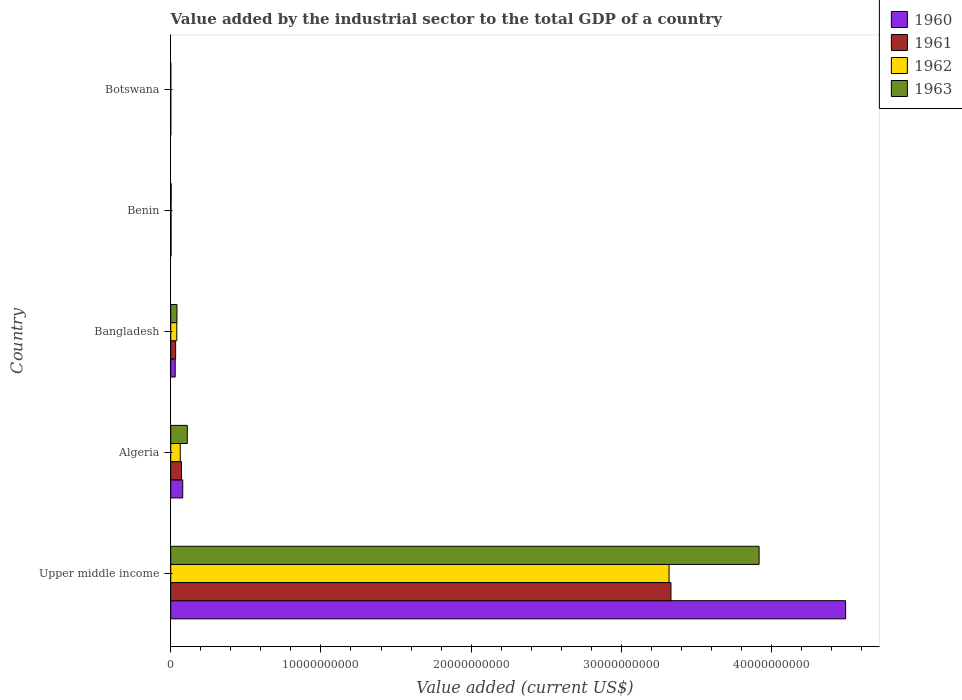How many groups of bars are there?
Provide a short and direct response. 5. Are the number of bars on each tick of the Y-axis equal?
Your response must be concise. Yes. How many bars are there on the 4th tick from the bottom?
Your response must be concise. 4. What is the label of the 5th group of bars from the top?
Your answer should be very brief. Upper middle income. What is the value added by the industrial sector to the total GDP in 1961 in Upper middle income?
Offer a terse response. 3.33e+1. Across all countries, what is the maximum value added by the industrial sector to the total GDP in 1963?
Provide a short and direct response. 3.92e+1. Across all countries, what is the minimum value added by the industrial sector to the total GDP in 1963?
Offer a terse response. 4.04e+06. In which country was the value added by the industrial sector to the total GDP in 1962 maximum?
Your answer should be very brief. Upper middle income. In which country was the value added by the industrial sector to the total GDP in 1962 minimum?
Keep it short and to the point. Botswana. What is the total value added by the industrial sector to the total GDP in 1963 in the graph?
Give a very brief answer. 4.07e+1. What is the difference between the value added by the industrial sector to the total GDP in 1962 in Bangladesh and that in Upper middle income?
Make the answer very short. -3.28e+1. What is the difference between the value added by the industrial sector to the total GDP in 1962 in Botswana and the value added by the industrial sector to the total GDP in 1960 in Bangladesh?
Provide a succinct answer. -2.94e+08. What is the average value added by the industrial sector to the total GDP in 1963 per country?
Your response must be concise. 8.15e+09. What is the difference between the value added by the industrial sector to the total GDP in 1961 and value added by the industrial sector to the total GDP in 1960 in Bangladesh?
Keep it short and to the point. 2.92e+07. What is the ratio of the value added by the industrial sector to the total GDP in 1960 in Benin to that in Botswana?
Make the answer very short. 5.71. Is the value added by the industrial sector to the total GDP in 1962 in Benin less than that in Botswana?
Keep it short and to the point. No. What is the difference between the highest and the second highest value added by the industrial sector to the total GDP in 1961?
Ensure brevity in your answer.  3.26e+1. What is the difference between the highest and the lowest value added by the industrial sector to the total GDP in 1962?
Your answer should be very brief. 3.32e+1. Is the sum of the value added by the industrial sector to the total GDP in 1961 in Benin and Botswana greater than the maximum value added by the industrial sector to the total GDP in 1960 across all countries?
Offer a terse response. No. Is it the case that in every country, the sum of the value added by the industrial sector to the total GDP in 1962 and value added by the industrial sector to the total GDP in 1963 is greater than the sum of value added by the industrial sector to the total GDP in 1961 and value added by the industrial sector to the total GDP in 1960?
Give a very brief answer. No. What does the 4th bar from the bottom in Benin represents?
Offer a terse response. 1963. Is it the case that in every country, the sum of the value added by the industrial sector to the total GDP in 1961 and value added by the industrial sector to the total GDP in 1960 is greater than the value added by the industrial sector to the total GDP in 1962?
Give a very brief answer. Yes. How many bars are there?
Offer a very short reply. 20. What is the difference between two consecutive major ticks on the X-axis?
Give a very brief answer. 1.00e+1. Does the graph contain any zero values?
Keep it short and to the point. No. Does the graph contain grids?
Make the answer very short. No. How are the legend labels stacked?
Your answer should be compact. Vertical. What is the title of the graph?
Ensure brevity in your answer.  Value added by the industrial sector to the total GDP of a country. What is the label or title of the X-axis?
Keep it short and to the point. Value added (current US$). What is the label or title of the Y-axis?
Keep it short and to the point. Country. What is the Value added (current US$) of 1960 in Upper middle income?
Ensure brevity in your answer.  4.49e+1. What is the Value added (current US$) in 1961 in Upper middle income?
Make the answer very short. 3.33e+1. What is the Value added (current US$) in 1962 in Upper middle income?
Offer a terse response. 3.32e+1. What is the Value added (current US$) in 1963 in Upper middle income?
Offer a very short reply. 3.92e+1. What is the Value added (current US$) in 1960 in Algeria?
Make the answer very short. 8.00e+08. What is the Value added (current US$) of 1961 in Algeria?
Give a very brief answer. 7.17e+08. What is the Value added (current US$) of 1962 in Algeria?
Make the answer very short. 6.34e+08. What is the Value added (current US$) in 1963 in Algeria?
Give a very brief answer. 1.10e+09. What is the Value added (current US$) of 1960 in Bangladesh?
Keep it short and to the point. 2.98e+08. What is the Value added (current US$) in 1961 in Bangladesh?
Ensure brevity in your answer.  3.27e+08. What is the Value added (current US$) of 1962 in Bangladesh?
Provide a short and direct response. 4.05e+08. What is the Value added (current US$) of 1963 in Bangladesh?
Provide a short and direct response. 4.15e+08. What is the Value added (current US$) of 1960 in Benin?
Keep it short and to the point. 2.31e+07. What is the Value added (current US$) of 1961 in Benin?
Keep it short and to the point. 2.31e+07. What is the Value added (current US$) of 1962 in Benin?
Provide a short and direct response. 2.32e+07. What is the Value added (current US$) in 1963 in Benin?
Provide a short and direct response. 2.91e+07. What is the Value added (current US$) of 1960 in Botswana?
Provide a succinct answer. 4.05e+06. What is the Value added (current US$) in 1961 in Botswana?
Your answer should be very brief. 4.05e+06. What is the Value added (current US$) of 1962 in Botswana?
Offer a very short reply. 4.05e+06. What is the Value added (current US$) of 1963 in Botswana?
Your answer should be compact. 4.04e+06. Across all countries, what is the maximum Value added (current US$) of 1960?
Your answer should be very brief. 4.49e+1. Across all countries, what is the maximum Value added (current US$) of 1961?
Provide a succinct answer. 3.33e+1. Across all countries, what is the maximum Value added (current US$) of 1962?
Your response must be concise. 3.32e+1. Across all countries, what is the maximum Value added (current US$) of 1963?
Provide a short and direct response. 3.92e+1. Across all countries, what is the minimum Value added (current US$) in 1960?
Keep it short and to the point. 4.05e+06. Across all countries, what is the minimum Value added (current US$) in 1961?
Ensure brevity in your answer.  4.05e+06. Across all countries, what is the minimum Value added (current US$) in 1962?
Provide a short and direct response. 4.05e+06. Across all countries, what is the minimum Value added (current US$) in 1963?
Offer a very short reply. 4.04e+06. What is the total Value added (current US$) in 1960 in the graph?
Your answer should be very brief. 4.61e+1. What is the total Value added (current US$) of 1961 in the graph?
Your answer should be compact. 3.44e+1. What is the total Value added (current US$) in 1962 in the graph?
Make the answer very short. 3.42e+1. What is the total Value added (current US$) of 1963 in the graph?
Provide a succinct answer. 4.07e+1. What is the difference between the Value added (current US$) in 1960 in Upper middle income and that in Algeria?
Offer a terse response. 4.41e+1. What is the difference between the Value added (current US$) of 1961 in Upper middle income and that in Algeria?
Provide a short and direct response. 3.26e+1. What is the difference between the Value added (current US$) of 1962 in Upper middle income and that in Algeria?
Keep it short and to the point. 3.25e+1. What is the difference between the Value added (current US$) of 1963 in Upper middle income and that in Algeria?
Your response must be concise. 3.81e+1. What is the difference between the Value added (current US$) in 1960 in Upper middle income and that in Bangladesh?
Offer a very short reply. 4.46e+1. What is the difference between the Value added (current US$) in 1961 in Upper middle income and that in Bangladesh?
Ensure brevity in your answer.  3.30e+1. What is the difference between the Value added (current US$) in 1962 in Upper middle income and that in Bangladesh?
Offer a very short reply. 3.28e+1. What is the difference between the Value added (current US$) of 1963 in Upper middle income and that in Bangladesh?
Provide a short and direct response. 3.88e+1. What is the difference between the Value added (current US$) in 1960 in Upper middle income and that in Benin?
Make the answer very short. 4.49e+1. What is the difference between the Value added (current US$) in 1961 in Upper middle income and that in Benin?
Your answer should be very brief. 3.33e+1. What is the difference between the Value added (current US$) in 1962 in Upper middle income and that in Benin?
Provide a succinct answer. 3.32e+1. What is the difference between the Value added (current US$) of 1963 in Upper middle income and that in Benin?
Offer a terse response. 3.91e+1. What is the difference between the Value added (current US$) of 1960 in Upper middle income and that in Botswana?
Keep it short and to the point. 4.49e+1. What is the difference between the Value added (current US$) in 1961 in Upper middle income and that in Botswana?
Ensure brevity in your answer.  3.33e+1. What is the difference between the Value added (current US$) in 1962 in Upper middle income and that in Botswana?
Ensure brevity in your answer.  3.32e+1. What is the difference between the Value added (current US$) of 1963 in Upper middle income and that in Botswana?
Your response must be concise. 3.92e+1. What is the difference between the Value added (current US$) of 1960 in Algeria and that in Bangladesh?
Give a very brief answer. 5.02e+08. What is the difference between the Value added (current US$) of 1961 in Algeria and that in Bangladesh?
Offer a very short reply. 3.90e+08. What is the difference between the Value added (current US$) of 1962 in Algeria and that in Bangladesh?
Provide a succinct answer. 2.30e+08. What is the difference between the Value added (current US$) of 1963 in Algeria and that in Bangladesh?
Provide a short and direct response. 6.88e+08. What is the difference between the Value added (current US$) of 1960 in Algeria and that in Benin?
Give a very brief answer. 7.77e+08. What is the difference between the Value added (current US$) in 1961 in Algeria and that in Benin?
Your answer should be compact. 6.94e+08. What is the difference between the Value added (current US$) in 1962 in Algeria and that in Benin?
Your answer should be compact. 6.11e+08. What is the difference between the Value added (current US$) of 1963 in Algeria and that in Benin?
Make the answer very short. 1.07e+09. What is the difference between the Value added (current US$) in 1960 in Algeria and that in Botswana?
Give a very brief answer. 7.96e+08. What is the difference between the Value added (current US$) in 1961 in Algeria and that in Botswana?
Give a very brief answer. 7.13e+08. What is the difference between the Value added (current US$) of 1962 in Algeria and that in Botswana?
Your response must be concise. 6.30e+08. What is the difference between the Value added (current US$) of 1963 in Algeria and that in Botswana?
Offer a very short reply. 1.10e+09. What is the difference between the Value added (current US$) of 1960 in Bangladesh and that in Benin?
Provide a short and direct response. 2.75e+08. What is the difference between the Value added (current US$) of 1961 in Bangladesh and that in Benin?
Provide a short and direct response. 3.04e+08. What is the difference between the Value added (current US$) in 1962 in Bangladesh and that in Benin?
Offer a terse response. 3.82e+08. What is the difference between the Value added (current US$) of 1963 in Bangladesh and that in Benin?
Your answer should be compact. 3.86e+08. What is the difference between the Value added (current US$) of 1960 in Bangladesh and that in Botswana?
Your answer should be compact. 2.94e+08. What is the difference between the Value added (current US$) of 1961 in Bangladesh and that in Botswana?
Your answer should be very brief. 3.23e+08. What is the difference between the Value added (current US$) of 1962 in Bangladesh and that in Botswana?
Offer a very short reply. 4.01e+08. What is the difference between the Value added (current US$) in 1963 in Bangladesh and that in Botswana?
Make the answer very short. 4.11e+08. What is the difference between the Value added (current US$) of 1960 in Benin and that in Botswana?
Make the answer very short. 1.91e+07. What is the difference between the Value added (current US$) of 1961 in Benin and that in Botswana?
Keep it short and to the point. 1.91e+07. What is the difference between the Value added (current US$) of 1962 in Benin and that in Botswana?
Your response must be concise. 1.91e+07. What is the difference between the Value added (current US$) of 1963 in Benin and that in Botswana?
Provide a short and direct response. 2.51e+07. What is the difference between the Value added (current US$) in 1960 in Upper middle income and the Value added (current US$) in 1961 in Algeria?
Your response must be concise. 4.42e+1. What is the difference between the Value added (current US$) of 1960 in Upper middle income and the Value added (current US$) of 1962 in Algeria?
Your response must be concise. 4.43e+1. What is the difference between the Value added (current US$) of 1960 in Upper middle income and the Value added (current US$) of 1963 in Algeria?
Provide a succinct answer. 4.38e+1. What is the difference between the Value added (current US$) in 1961 in Upper middle income and the Value added (current US$) in 1962 in Algeria?
Offer a very short reply. 3.27e+1. What is the difference between the Value added (current US$) in 1961 in Upper middle income and the Value added (current US$) in 1963 in Algeria?
Ensure brevity in your answer.  3.22e+1. What is the difference between the Value added (current US$) of 1962 in Upper middle income and the Value added (current US$) of 1963 in Algeria?
Give a very brief answer. 3.21e+1. What is the difference between the Value added (current US$) of 1960 in Upper middle income and the Value added (current US$) of 1961 in Bangladesh?
Ensure brevity in your answer.  4.46e+1. What is the difference between the Value added (current US$) of 1960 in Upper middle income and the Value added (current US$) of 1962 in Bangladesh?
Give a very brief answer. 4.45e+1. What is the difference between the Value added (current US$) in 1960 in Upper middle income and the Value added (current US$) in 1963 in Bangladesh?
Your answer should be very brief. 4.45e+1. What is the difference between the Value added (current US$) in 1961 in Upper middle income and the Value added (current US$) in 1962 in Bangladesh?
Keep it short and to the point. 3.29e+1. What is the difference between the Value added (current US$) in 1961 in Upper middle income and the Value added (current US$) in 1963 in Bangladesh?
Offer a terse response. 3.29e+1. What is the difference between the Value added (current US$) of 1962 in Upper middle income and the Value added (current US$) of 1963 in Bangladesh?
Your response must be concise. 3.28e+1. What is the difference between the Value added (current US$) in 1960 in Upper middle income and the Value added (current US$) in 1961 in Benin?
Give a very brief answer. 4.49e+1. What is the difference between the Value added (current US$) of 1960 in Upper middle income and the Value added (current US$) of 1962 in Benin?
Offer a very short reply. 4.49e+1. What is the difference between the Value added (current US$) of 1960 in Upper middle income and the Value added (current US$) of 1963 in Benin?
Give a very brief answer. 4.49e+1. What is the difference between the Value added (current US$) of 1961 in Upper middle income and the Value added (current US$) of 1962 in Benin?
Give a very brief answer. 3.33e+1. What is the difference between the Value added (current US$) of 1961 in Upper middle income and the Value added (current US$) of 1963 in Benin?
Make the answer very short. 3.33e+1. What is the difference between the Value added (current US$) in 1962 in Upper middle income and the Value added (current US$) in 1963 in Benin?
Your answer should be very brief. 3.31e+1. What is the difference between the Value added (current US$) of 1960 in Upper middle income and the Value added (current US$) of 1961 in Botswana?
Your answer should be compact. 4.49e+1. What is the difference between the Value added (current US$) in 1960 in Upper middle income and the Value added (current US$) in 1962 in Botswana?
Your answer should be compact. 4.49e+1. What is the difference between the Value added (current US$) in 1960 in Upper middle income and the Value added (current US$) in 1963 in Botswana?
Give a very brief answer. 4.49e+1. What is the difference between the Value added (current US$) of 1961 in Upper middle income and the Value added (current US$) of 1962 in Botswana?
Your response must be concise. 3.33e+1. What is the difference between the Value added (current US$) in 1961 in Upper middle income and the Value added (current US$) in 1963 in Botswana?
Make the answer very short. 3.33e+1. What is the difference between the Value added (current US$) of 1962 in Upper middle income and the Value added (current US$) of 1963 in Botswana?
Provide a short and direct response. 3.32e+1. What is the difference between the Value added (current US$) in 1960 in Algeria and the Value added (current US$) in 1961 in Bangladesh?
Keep it short and to the point. 4.73e+08. What is the difference between the Value added (current US$) in 1960 in Algeria and the Value added (current US$) in 1962 in Bangladesh?
Ensure brevity in your answer.  3.95e+08. What is the difference between the Value added (current US$) in 1960 in Algeria and the Value added (current US$) in 1963 in Bangladesh?
Ensure brevity in your answer.  3.85e+08. What is the difference between the Value added (current US$) of 1961 in Algeria and the Value added (current US$) of 1962 in Bangladesh?
Provide a short and direct response. 3.12e+08. What is the difference between the Value added (current US$) in 1961 in Algeria and the Value added (current US$) in 1963 in Bangladesh?
Your answer should be compact. 3.02e+08. What is the difference between the Value added (current US$) of 1962 in Algeria and the Value added (current US$) of 1963 in Bangladesh?
Offer a very short reply. 2.19e+08. What is the difference between the Value added (current US$) of 1960 in Algeria and the Value added (current US$) of 1961 in Benin?
Ensure brevity in your answer.  7.77e+08. What is the difference between the Value added (current US$) of 1960 in Algeria and the Value added (current US$) of 1962 in Benin?
Offer a terse response. 7.77e+08. What is the difference between the Value added (current US$) in 1960 in Algeria and the Value added (current US$) in 1963 in Benin?
Give a very brief answer. 7.71e+08. What is the difference between the Value added (current US$) in 1961 in Algeria and the Value added (current US$) in 1962 in Benin?
Give a very brief answer. 6.94e+08. What is the difference between the Value added (current US$) in 1961 in Algeria and the Value added (current US$) in 1963 in Benin?
Your response must be concise. 6.88e+08. What is the difference between the Value added (current US$) of 1962 in Algeria and the Value added (current US$) of 1963 in Benin?
Offer a terse response. 6.05e+08. What is the difference between the Value added (current US$) of 1960 in Algeria and the Value added (current US$) of 1961 in Botswana?
Ensure brevity in your answer.  7.96e+08. What is the difference between the Value added (current US$) in 1960 in Algeria and the Value added (current US$) in 1962 in Botswana?
Your answer should be very brief. 7.96e+08. What is the difference between the Value added (current US$) in 1960 in Algeria and the Value added (current US$) in 1963 in Botswana?
Keep it short and to the point. 7.96e+08. What is the difference between the Value added (current US$) of 1961 in Algeria and the Value added (current US$) of 1962 in Botswana?
Provide a short and direct response. 7.13e+08. What is the difference between the Value added (current US$) in 1961 in Algeria and the Value added (current US$) in 1963 in Botswana?
Keep it short and to the point. 7.13e+08. What is the difference between the Value added (current US$) in 1962 in Algeria and the Value added (current US$) in 1963 in Botswana?
Offer a terse response. 6.30e+08. What is the difference between the Value added (current US$) of 1960 in Bangladesh and the Value added (current US$) of 1961 in Benin?
Offer a very short reply. 2.75e+08. What is the difference between the Value added (current US$) in 1960 in Bangladesh and the Value added (current US$) in 1962 in Benin?
Your answer should be compact. 2.75e+08. What is the difference between the Value added (current US$) of 1960 in Bangladesh and the Value added (current US$) of 1963 in Benin?
Your answer should be compact. 2.69e+08. What is the difference between the Value added (current US$) in 1961 in Bangladesh and the Value added (current US$) in 1962 in Benin?
Offer a very short reply. 3.04e+08. What is the difference between the Value added (current US$) in 1961 in Bangladesh and the Value added (current US$) in 1963 in Benin?
Keep it short and to the point. 2.98e+08. What is the difference between the Value added (current US$) in 1962 in Bangladesh and the Value added (current US$) in 1963 in Benin?
Your answer should be very brief. 3.76e+08. What is the difference between the Value added (current US$) in 1960 in Bangladesh and the Value added (current US$) in 1961 in Botswana?
Your answer should be compact. 2.94e+08. What is the difference between the Value added (current US$) in 1960 in Bangladesh and the Value added (current US$) in 1962 in Botswana?
Make the answer very short. 2.94e+08. What is the difference between the Value added (current US$) in 1960 in Bangladesh and the Value added (current US$) in 1963 in Botswana?
Make the answer very short. 2.94e+08. What is the difference between the Value added (current US$) in 1961 in Bangladesh and the Value added (current US$) in 1962 in Botswana?
Ensure brevity in your answer.  3.23e+08. What is the difference between the Value added (current US$) of 1961 in Bangladesh and the Value added (current US$) of 1963 in Botswana?
Offer a very short reply. 3.23e+08. What is the difference between the Value added (current US$) in 1962 in Bangladesh and the Value added (current US$) in 1963 in Botswana?
Your answer should be compact. 4.01e+08. What is the difference between the Value added (current US$) in 1960 in Benin and the Value added (current US$) in 1961 in Botswana?
Your answer should be very brief. 1.91e+07. What is the difference between the Value added (current US$) in 1960 in Benin and the Value added (current US$) in 1962 in Botswana?
Provide a short and direct response. 1.91e+07. What is the difference between the Value added (current US$) of 1960 in Benin and the Value added (current US$) of 1963 in Botswana?
Your answer should be very brief. 1.91e+07. What is the difference between the Value added (current US$) in 1961 in Benin and the Value added (current US$) in 1962 in Botswana?
Your answer should be compact. 1.91e+07. What is the difference between the Value added (current US$) of 1961 in Benin and the Value added (current US$) of 1963 in Botswana?
Your answer should be compact. 1.91e+07. What is the difference between the Value added (current US$) of 1962 in Benin and the Value added (current US$) of 1963 in Botswana?
Your response must be concise. 1.91e+07. What is the average Value added (current US$) of 1960 per country?
Keep it short and to the point. 9.21e+09. What is the average Value added (current US$) of 1961 per country?
Make the answer very short. 6.88e+09. What is the average Value added (current US$) of 1962 per country?
Your answer should be very brief. 6.85e+09. What is the average Value added (current US$) of 1963 per country?
Make the answer very short. 8.15e+09. What is the difference between the Value added (current US$) in 1960 and Value added (current US$) in 1961 in Upper middle income?
Provide a short and direct response. 1.16e+1. What is the difference between the Value added (current US$) in 1960 and Value added (current US$) in 1962 in Upper middle income?
Your answer should be very brief. 1.18e+1. What is the difference between the Value added (current US$) in 1960 and Value added (current US$) in 1963 in Upper middle income?
Offer a terse response. 5.76e+09. What is the difference between the Value added (current US$) of 1961 and Value added (current US$) of 1962 in Upper middle income?
Keep it short and to the point. 1.26e+08. What is the difference between the Value added (current US$) of 1961 and Value added (current US$) of 1963 in Upper middle income?
Your response must be concise. -5.87e+09. What is the difference between the Value added (current US$) in 1962 and Value added (current US$) in 1963 in Upper middle income?
Your response must be concise. -5.99e+09. What is the difference between the Value added (current US$) in 1960 and Value added (current US$) in 1961 in Algeria?
Make the answer very short. 8.27e+07. What is the difference between the Value added (current US$) in 1960 and Value added (current US$) in 1962 in Algeria?
Provide a short and direct response. 1.65e+08. What is the difference between the Value added (current US$) of 1960 and Value added (current US$) of 1963 in Algeria?
Your answer should be compact. -3.03e+08. What is the difference between the Value added (current US$) of 1961 and Value added (current US$) of 1962 in Algeria?
Make the answer very short. 8.27e+07. What is the difference between the Value added (current US$) in 1961 and Value added (current US$) in 1963 in Algeria?
Ensure brevity in your answer.  -3.86e+08. What is the difference between the Value added (current US$) of 1962 and Value added (current US$) of 1963 in Algeria?
Ensure brevity in your answer.  -4.69e+08. What is the difference between the Value added (current US$) of 1960 and Value added (current US$) of 1961 in Bangladesh?
Give a very brief answer. -2.92e+07. What is the difference between the Value added (current US$) in 1960 and Value added (current US$) in 1962 in Bangladesh?
Make the answer very short. -1.07e+08. What is the difference between the Value added (current US$) in 1960 and Value added (current US$) in 1963 in Bangladesh?
Make the answer very short. -1.17e+08. What is the difference between the Value added (current US$) of 1961 and Value added (current US$) of 1962 in Bangladesh?
Keep it short and to the point. -7.74e+07. What is the difference between the Value added (current US$) in 1961 and Value added (current US$) in 1963 in Bangladesh?
Your response must be concise. -8.78e+07. What is the difference between the Value added (current US$) in 1962 and Value added (current US$) in 1963 in Bangladesh?
Keep it short and to the point. -1.05e+07. What is the difference between the Value added (current US$) of 1960 and Value added (current US$) of 1961 in Benin?
Provide a short and direct response. 6130.83. What is the difference between the Value added (current US$) of 1960 and Value added (current US$) of 1962 in Benin?
Your answer should be very brief. -1.71e+04. What is the difference between the Value added (current US$) of 1960 and Value added (current US$) of 1963 in Benin?
Your response must be concise. -5.99e+06. What is the difference between the Value added (current US$) in 1961 and Value added (current US$) in 1962 in Benin?
Provide a short and direct response. -2.32e+04. What is the difference between the Value added (current US$) of 1961 and Value added (current US$) of 1963 in Benin?
Give a very brief answer. -6.00e+06. What is the difference between the Value added (current US$) in 1962 and Value added (current US$) in 1963 in Benin?
Your answer should be compact. -5.97e+06. What is the difference between the Value added (current US$) of 1960 and Value added (current US$) of 1961 in Botswana?
Your answer should be very brief. 7791.27. What is the difference between the Value added (current US$) in 1960 and Value added (current US$) in 1962 in Botswana?
Ensure brevity in your answer.  -314.81. What is the difference between the Value added (current US$) of 1960 and Value added (current US$) of 1963 in Botswana?
Your answer should be very brief. 1.11e+04. What is the difference between the Value added (current US$) of 1961 and Value added (current US$) of 1962 in Botswana?
Offer a very short reply. -8106.08. What is the difference between the Value added (current US$) of 1961 and Value added (current US$) of 1963 in Botswana?
Provide a short and direct response. 3353.04. What is the difference between the Value added (current US$) of 1962 and Value added (current US$) of 1963 in Botswana?
Offer a terse response. 1.15e+04. What is the ratio of the Value added (current US$) in 1960 in Upper middle income to that in Algeria?
Your answer should be compact. 56.17. What is the ratio of the Value added (current US$) of 1961 in Upper middle income to that in Algeria?
Your response must be concise. 46.44. What is the ratio of the Value added (current US$) in 1962 in Upper middle income to that in Algeria?
Keep it short and to the point. 52.3. What is the ratio of the Value added (current US$) in 1963 in Upper middle income to that in Algeria?
Offer a very short reply. 35.5. What is the ratio of the Value added (current US$) in 1960 in Upper middle income to that in Bangladesh?
Your answer should be compact. 150.72. What is the ratio of the Value added (current US$) in 1961 in Upper middle income to that in Bangladesh?
Make the answer very short. 101.75. What is the ratio of the Value added (current US$) in 1962 in Upper middle income to that in Bangladesh?
Provide a short and direct response. 81.99. What is the ratio of the Value added (current US$) in 1963 in Upper middle income to that in Bangladesh?
Your answer should be compact. 94.36. What is the ratio of the Value added (current US$) of 1960 in Upper middle income to that in Benin?
Your answer should be compact. 1942.42. What is the ratio of the Value added (current US$) in 1961 in Upper middle income to that in Benin?
Keep it short and to the point. 1440.1. What is the ratio of the Value added (current US$) of 1962 in Upper middle income to that in Benin?
Give a very brief answer. 1433.2. What is the ratio of the Value added (current US$) in 1963 in Upper middle income to that in Benin?
Offer a terse response. 1345.05. What is the ratio of the Value added (current US$) in 1960 in Upper middle income to that in Botswana?
Give a very brief answer. 1.11e+04. What is the ratio of the Value added (current US$) in 1961 in Upper middle income to that in Botswana?
Make the answer very short. 8231.16. What is the ratio of the Value added (current US$) of 1962 in Upper middle income to that in Botswana?
Give a very brief answer. 8183.55. What is the ratio of the Value added (current US$) of 1963 in Upper middle income to that in Botswana?
Your response must be concise. 9689.55. What is the ratio of the Value added (current US$) in 1960 in Algeria to that in Bangladesh?
Give a very brief answer. 2.68. What is the ratio of the Value added (current US$) in 1961 in Algeria to that in Bangladesh?
Offer a terse response. 2.19. What is the ratio of the Value added (current US$) in 1962 in Algeria to that in Bangladesh?
Your response must be concise. 1.57. What is the ratio of the Value added (current US$) of 1963 in Algeria to that in Bangladesh?
Your response must be concise. 2.66. What is the ratio of the Value added (current US$) of 1960 in Algeria to that in Benin?
Your answer should be very brief. 34.58. What is the ratio of the Value added (current US$) of 1961 in Algeria to that in Benin?
Make the answer very short. 31.01. What is the ratio of the Value added (current US$) in 1962 in Algeria to that in Benin?
Keep it short and to the point. 27.4. What is the ratio of the Value added (current US$) in 1963 in Algeria to that in Benin?
Offer a terse response. 37.88. What is the ratio of the Value added (current US$) of 1960 in Algeria to that in Botswana?
Provide a short and direct response. 197.31. What is the ratio of the Value added (current US$) of 1961 in Algeria to that in Botswana?
Give a very brief answer. 177.24. What is the ratio of the Value added (current US$) in 1962 in Algeria to that in Botswana?
Offer a very short reply. 156.48. What is the ratio of the Value added (current US$) in 1963 in Algeria to that in Botswana?
Your answer should be very brief. 272.91. What is the ratio of the Value added (current US$) of 1960 in Bangladesh to that in Benin?
Your answer should be very brief. 12.89. What is the ratio of the Value added (current US$) of 1961 in Bangladesh to that in Benin?
Ensure brevity in your answer.  14.15. What is the ratio of the Value added (current US$) of 1962 in Bangladesh to that in Benin?
Your answer should be very brief. 17.48. What is the ratio of the Value added (current US$) in 1963 in Bangladesh to that in Benin?
Provide a short and direct response. 14.26. What is the ratio of the Value added (current US$) in 1960 in Bangladesh to that in Botswana?
Provide a short and direct response. 73.54. What is the ratio of the Value added (current US$) of 1961 in Bangladesh to that in Botswana?
Ensure brevity in your answer.  80.89. What is the ratio of the Value added (current US$) of 1962 in Bangladesh to that in Botswana?
Give a very brief answer. 99.81. What is the ratio of the Value added (current US$) in 1963 in Bangladesh to that in Botswana?
Your response must be concise. 102.69. What is the ratio of the Value added (current US$) in 1960 in Benin to that in Botswana?
Keep it short and to the point. 5.71. What is the ratio of the Value added (current US$) of 1961 in Benin to that in Botswana?
Give a very brief answer. 5.72. What is the ratio of the Value added (current US$) in 1962 in Benin to that in Botswana?
Your answer should be compact. 5.71. What is the ratio of the Value added (current US$) of 1963 in Benin to that in Botswana?
Provide a short and direct response. 7.2. What is the difference between the highest and the second highest Value added (current US$) in 1960?
Make the answer very short. 4.41e+1. What is the difference between the highest and the second highest Value added (current US$) of 1961?
Your answer should be compact. 3.26e+1. What is the difference between the highest and the second highest Value added (current US$) of 1962?
Provide a short and direct response. 3.25e+1. What is the difference between the highest and the second highest Value added (current US$) of 1963?
Your answer should be compact. 3.81e+1. What is the difference between the highest and the lowest Value added (current US$) in 1960?
Your response must be concise. 4.49e+1. What is the difference between the highest and the lowest Value added (current US$) of 1961?
Make the answer very short. 3.33e+1. What is the difference between the highest and the lowest Value added (current US$) in 1962?
Make the answer very short. 3.32e+1. What is the difference between the highest and the lowest Value added (current US$) in 1963?
Provide a short and direct response. 3.92e+1. 